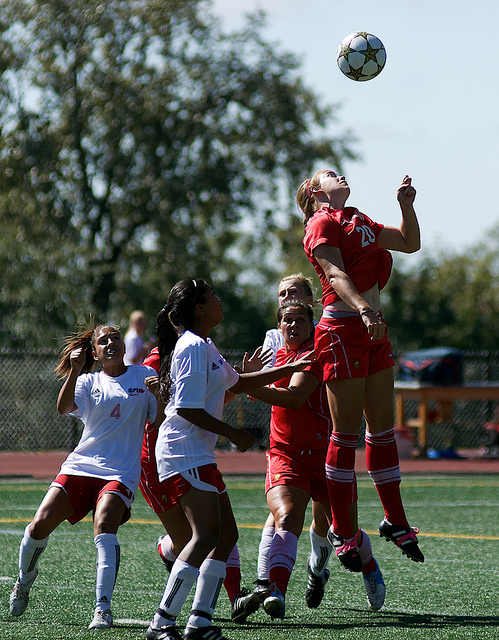Identify and read out the text in this image. 20 4 